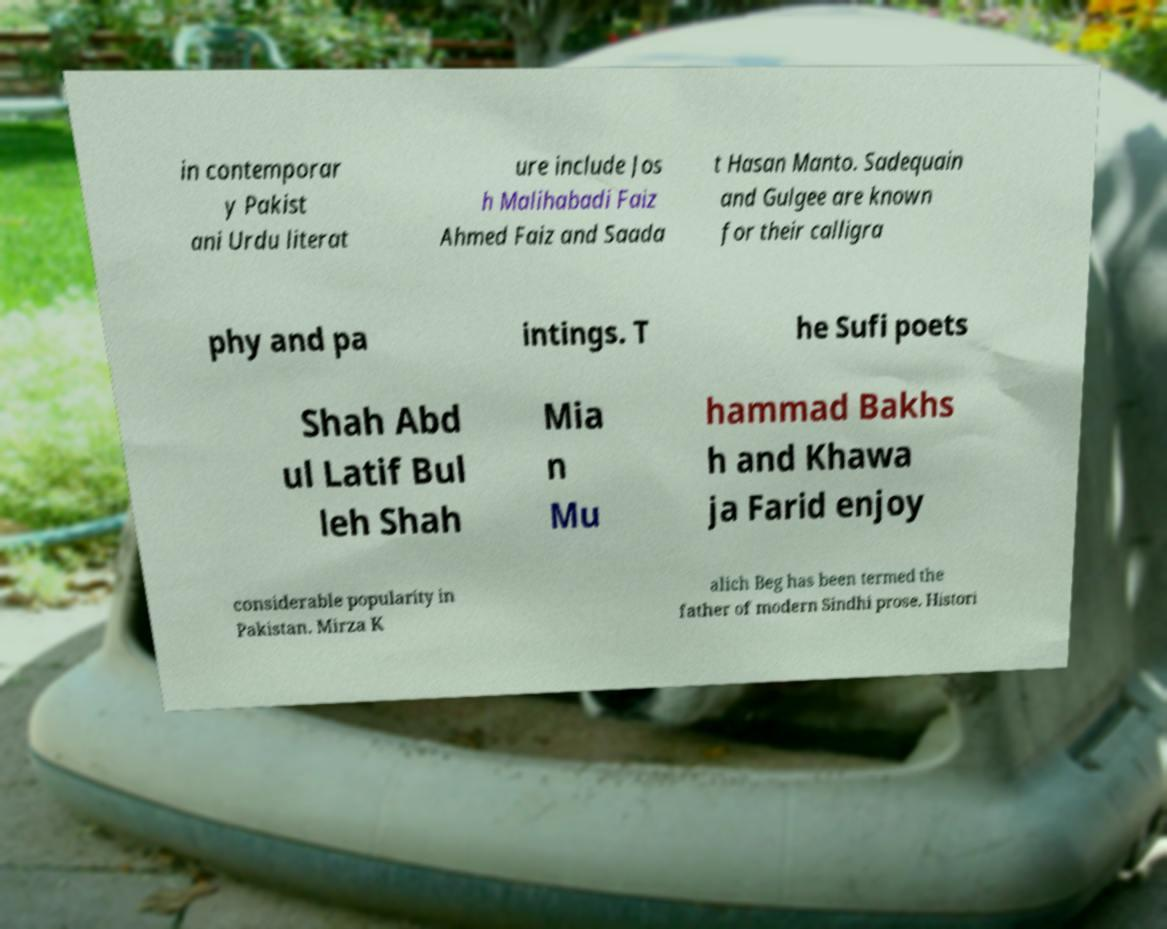Please identify and transcribe the text found in this image. in contemporar y Pakist ani Urdu literat ure include Jos h Malihabadi Faiz Ahmed Faiz and Saada t Hasan Manto. Sadequain and Gulgee are known for their calligra phy and pa intings. T he Sufi poets Shah Abd ul Latif Bul leh Shah Mia n Mu hammad Bakhs h and Khawa ja Farid enjoy considerable popularity in Pakistan. Mirza K alich Beg has been termed the father of modern Sindhi prose. Histori 